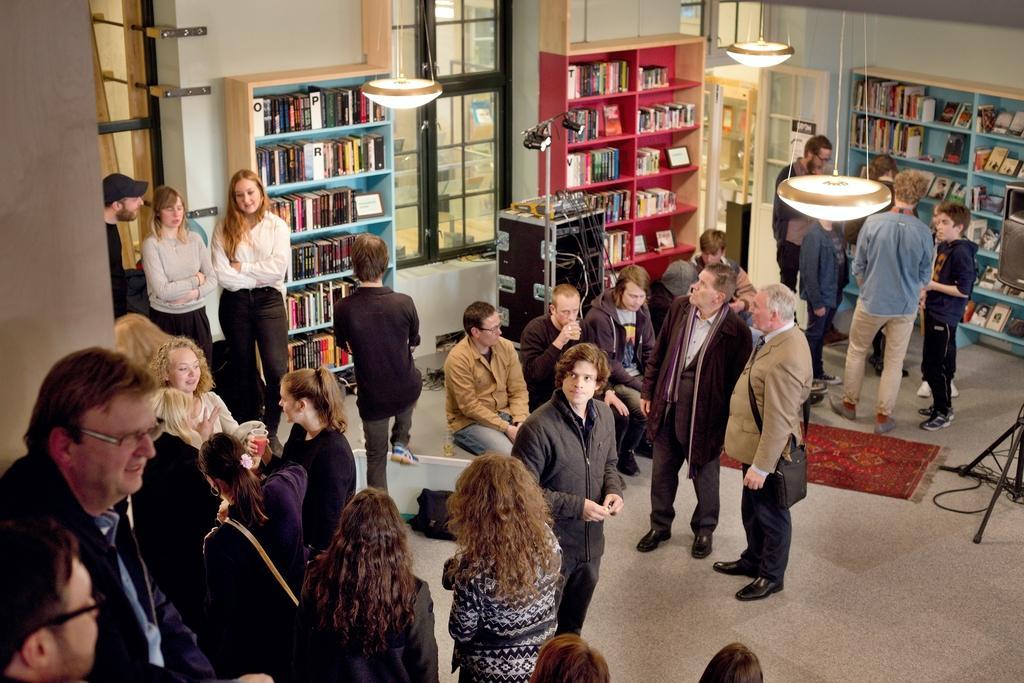Describe this image in one or two sentences. In this image we can see persons standing on the floor and some are sitting on the seating stools. In the background we can see books arranged in the cupboards, electric lights hanged from the roof, carpet, cables, windows and tripod. 